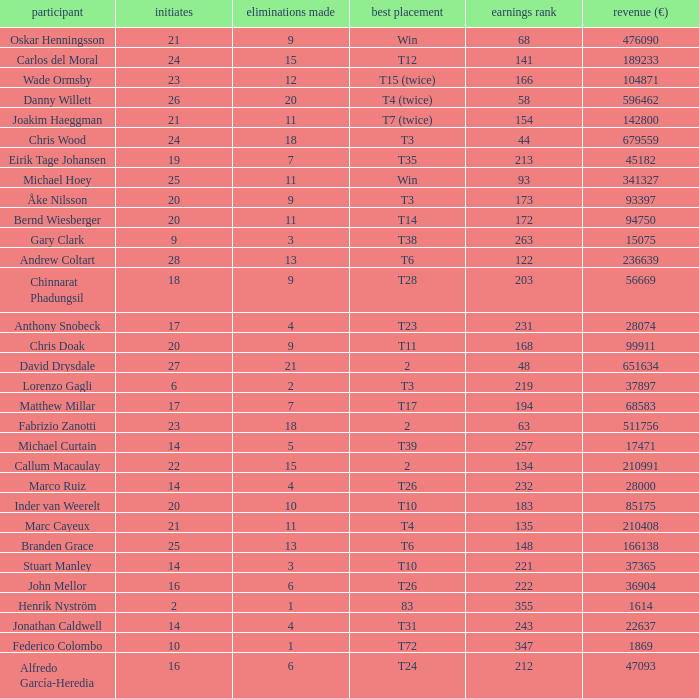Which player made exactly 26 starts? Danny Willett. Would you be able to parse every entry in this table? {'header': ['participant', 'initiates', 'eliminations made', 'best placement', 'earnings rank', 'revenue (€)'], 'rows': [['Oskar Henningsson', '21', '9', 'Win', '68', '476090'], ['Carlos del Moral', '24', '15', 'T12', '141', '189233'], ['Wade Ormsby', '23', '12', 'T15 (twice)', '166', '104871'], ['Danny Willett', '26', '20', 'T4 (twice)', '58', '596462'], ['Joakim Haeggman', '21', '11', 'T7 (twice)', '154', '142800'], ['Chris Wood', '24', '18', 'T3', '44', '679559'], ['Eirik Tage Johansen', '19', '7', 'T35', '213', '45182'], ['Michael Hoey', '25', '11', 'Win', '93', '341327'], ['Åke Nilsson', '20', '9', 'T3', '173', '93397'], ['Bernd Wiesberger', '20', '11', 'T14', '172', '94750'], ['Gary Clark', '9', '3', 'T38', '263', '15075'], ['Andrew Coltart', '28', '13', 'T6', '122', '236639'], ['Chinnarat Phadungsil', '18', '9', 'T28', '203', '56669'], ['Anthony Snobeck', '17', '4', 'T23', '231', '28074'], ['Chris Doak', '20', '9', 'T11', '168', '99911'], ['David Drysdale', '27', '21', '2', '48', '651634'], ['Lorenzo Gagli', '6', '2', 'T3', '219', '37897'], ['Matthew Millar', '17', '7', 'T17', '194', '68583'], ['Fabrizio Zanotti', '23', '18', '2', '63', '511756'], ['Michael Curtain', '14', '5', 'T39', '257', '17471'], ['Callum Macaulay', '22', '15', '2', '134', '210991'], ['Marco Ruiz', '14', '4', 'T26', '232', '28000'], ['Inder van Weerelt', '20', '10', 'T10', '183', '85175'], ['Marc Cayeux', '21', '11', 'T4', '135', '210408'], ['Branden Grace', '25', '13', 'T6', '148', '166138'], ['Stuart Manley', '14', '3', 'T10', '221', '37365'], ['John Mellor', '16', '6', 'T26', '222', '36904'], ['Henrik Nyström', '2', '1', '83', '355', '1614'], ['Jonathan Caldwell', '14', '4', 'T31', '243', '22637'], ['Federico Colombo', '10', '1', 'T72', '347', '1869'], ['Alfredo García-Heredia', '16', '6', 'T24', '212', '47093']]} 